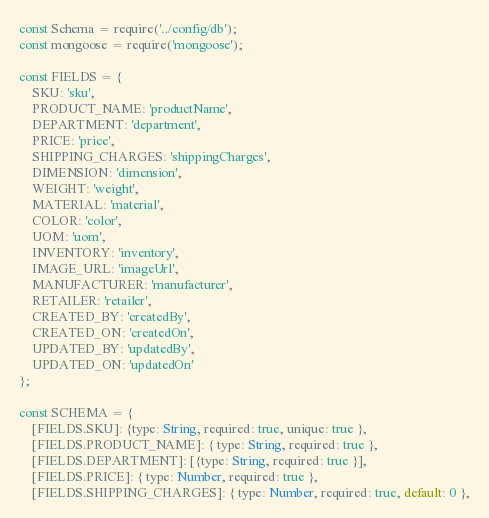Convert code to text. <code><loc_0><loc_0><loc_500><loc_500><_JavaScript_>const Schema = require('../config/db');
const mongoose = require('mongoose');

const FIELDS = {
    SKU: 'sku',
    PRODUCT_NAME: 'productName',
    DEPARTMENT: 'department',
    PRICE: 'price',
    SHIPPING_CHARGES: 'shippingCharges',
    DIMENSION: 'dimension',
    WEIGHT: 'weight',
    MATERIAL: 'material',
    COLOR: 'color',
    UOM: 'uom',
    INVENTORY: 'inventory',
    IMAGE_URL: 'imageUrl',
    MANUFACTURER: 'manufacturer',
    RETAILER: 'retailer',
    CREATED_BY: 'createdBy',
    CREATED_ON: 'createdOn',
    UPDATED_BY: 'updatedBy',
    UPDATED_ON: 'updatedOn'
};

const SCHEMA = {
    [FIELDS.SKU]: {type: String, required: true, unique: true },
    [FIELDS.PRODUCT_NAME]: { type: String, required: true },
    [FIELDS.DEPARTMENT]: [{type: String, required: true }],
    [FIELDS.PRICE]: { type: Number, required: true },
    [FIELDS.SHIPPING_CHARGES]: { type: Number, required: true, default: 0 },</code> 